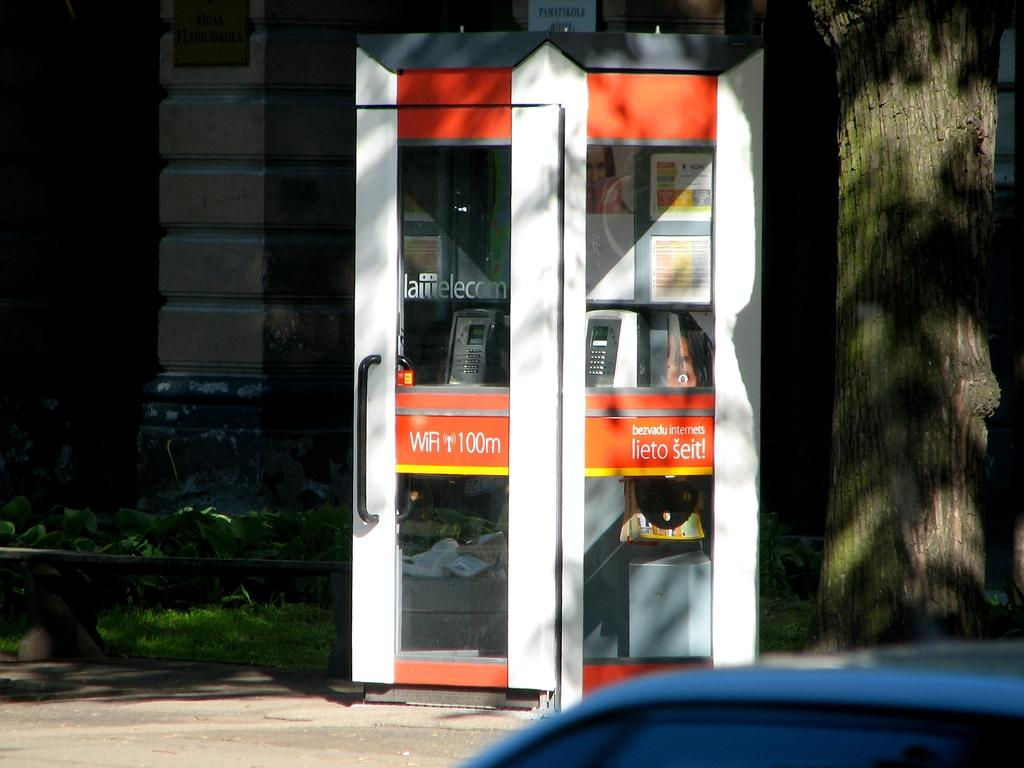What structure is present in the image? There is a telephone booth in the image. What type of surface can be seen in the image? The ground with grass is visible in the image. What is the main feature of the background in the image? There is a wall in the image. What can be seen in the bottom right corner of the image? There is a blue color object in the bottom right corner of the image. How does the feeling of happiness manifest itself in the image? The image does not depict any emotions or feelings; it is a static representation of a telephone booth, a wall, a road, and other elements. 